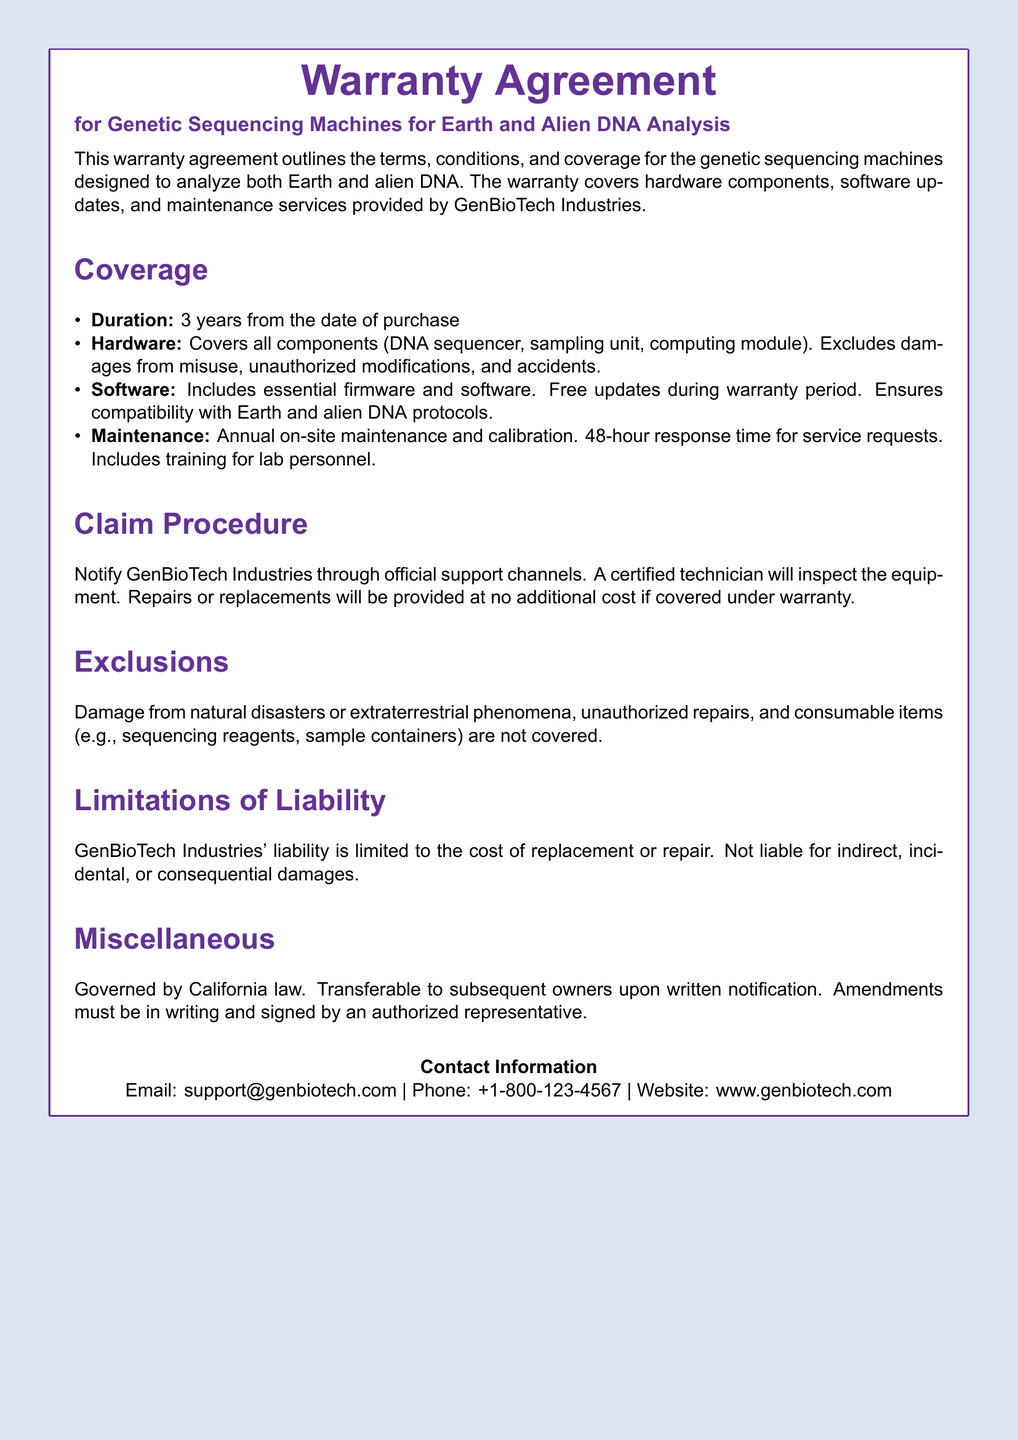What is the duration of the warranty? The warranty duration is specified as 3 years from the date of purchase.
Answer: 3 years What components are covered under hardware? The warranty covers all components: DNA sequencer, sampling unit, and computing module.
Answer: DNA sequencer, sampling unit, computing module What is included in the software coverage? The software coverage includes essential firmware and software, with free updates during the warranty period.
Answer: Essential firmware and software What is the response time for service requests? The document states a 48-hour response time for service requests.
Answer: 48 hours What damages are explicitly excluded from the warranty coverage? The exclusions mention damage from natural disasters or extraterrestrial phenomena, unauthorized repairs, and consumable items.
Answer: Natural disasters or extraterrestrial phenomena What is the limitation of liability for GenBioTech Industries? The limitation of liability is that it is limited to the cost of replacement or repair.
Answer: Cost of replacement or repair Where should claims be notified? The document indicates that claims should be notified through official support channels provided by GenBioTech Industries.
Answer: Official support channels Is the warranty transferable? Yes, the warranty is transferable to subsequent owners upon written notification.
Answer: Yes 